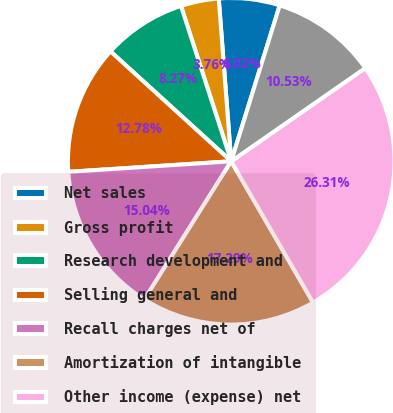Convert chart to OTSL. <chart><loc_0><loc_0><loc_500><loc_500><pie_chart><fcel>Net sales<fcel>Gross profit<fcel>Research development and<fcel>Selling general and<fcel>Recall charges net of<fcel>Amortization of intangible<fcel>Other income (expense) net<fcel>Net earnings<nl><fcel>6.02%<fcel>3.76%<fcel>8.27%<fcel>12.78%<fcel>15.04%<fcel>17.29%<fcel>26.31%<fcel>10.53%<nl></chart> 